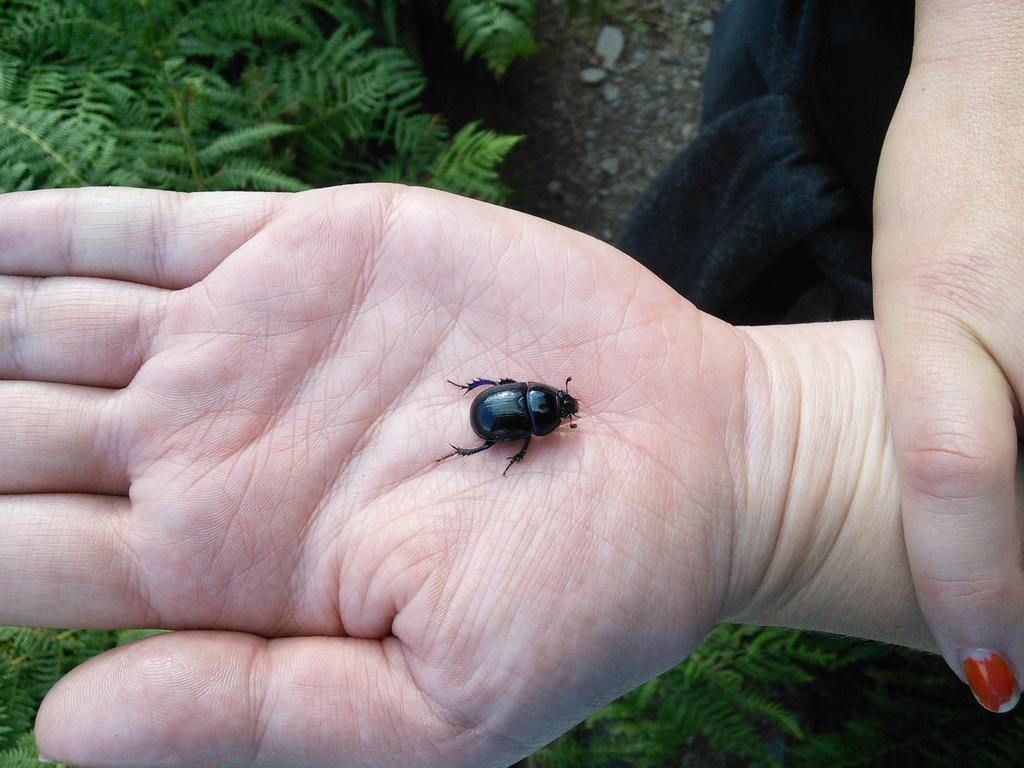What is on the person's hand in the image? There is a black inset on the person's hand. What is the woman wearing in the image? There is a woman wearing a black dress in the image. Where is the green plant located in the image? The green plant is in the top left corner of the image. What type of grain is being discussed by the lawyer in the image? There is no lawyer or grain present in the image. How does the peace symbol relate to the black inset on the person's hand in the image? There is no peace symbol present in the image, and the black inset on the person's hand is not related to any peace symbol. 